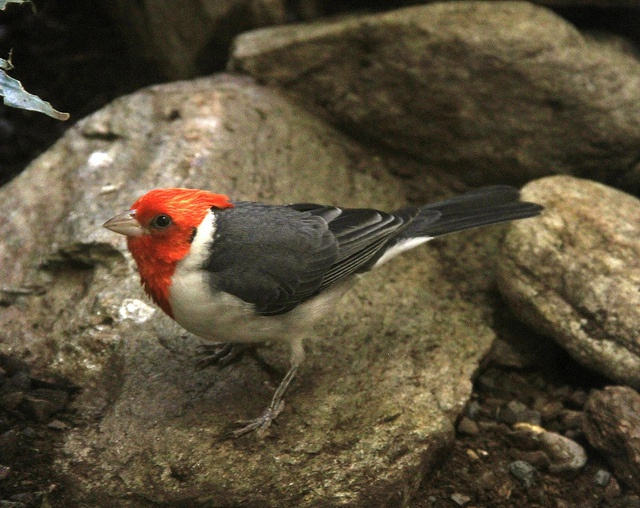Describe the objects in this image and their specific colors. I can see a bird in gray, black, darkgreen, and maroon tones in this image. 